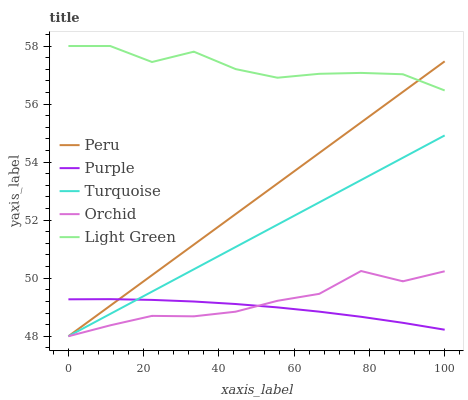Does Purple have the minimum area under the curve?
Answer yes or no. Yes. Does Light Green have the maximum area under the curve?
Answer yes or no. Yes. Does Turquoise have the minimum area under the curve?
Answer yes or no. No. Does Turquoise have the maximum area under the curve?
Answer yes or no. No. Is Turquoise the smoothest?
Answer yes or no. Yes. Is Light Green the roughest?
Answer yes or no. Yes. Is Light Green the smoothest?
Answer yes or no. No. Is Turquoise the roughest?
Answer yes or no. No. Does Turquoise have the lowest value?
Answer yes or no. Yes. Does Light Green have the lowest value?
Answer yes or no. No. Does Light Green have the highest value?
Answer yes or no. Yes. Does Turquoise have the highest value?
Answer yes or no. No. Is Turquoise less than Light Green?
Answer yes or no. Yes. Is Light Green greater than Orchid?
Answer yes or no. Yes. Does Peru intersect Turquoise?
Answer yes or no. Yes. Is Peru less than Turquoise?
Answer yes or no. No. Is Peru greater than Turquoise?
Answer yes or no. No. Does Turquoise intersect Light Green?
Answer yes or no. No. 